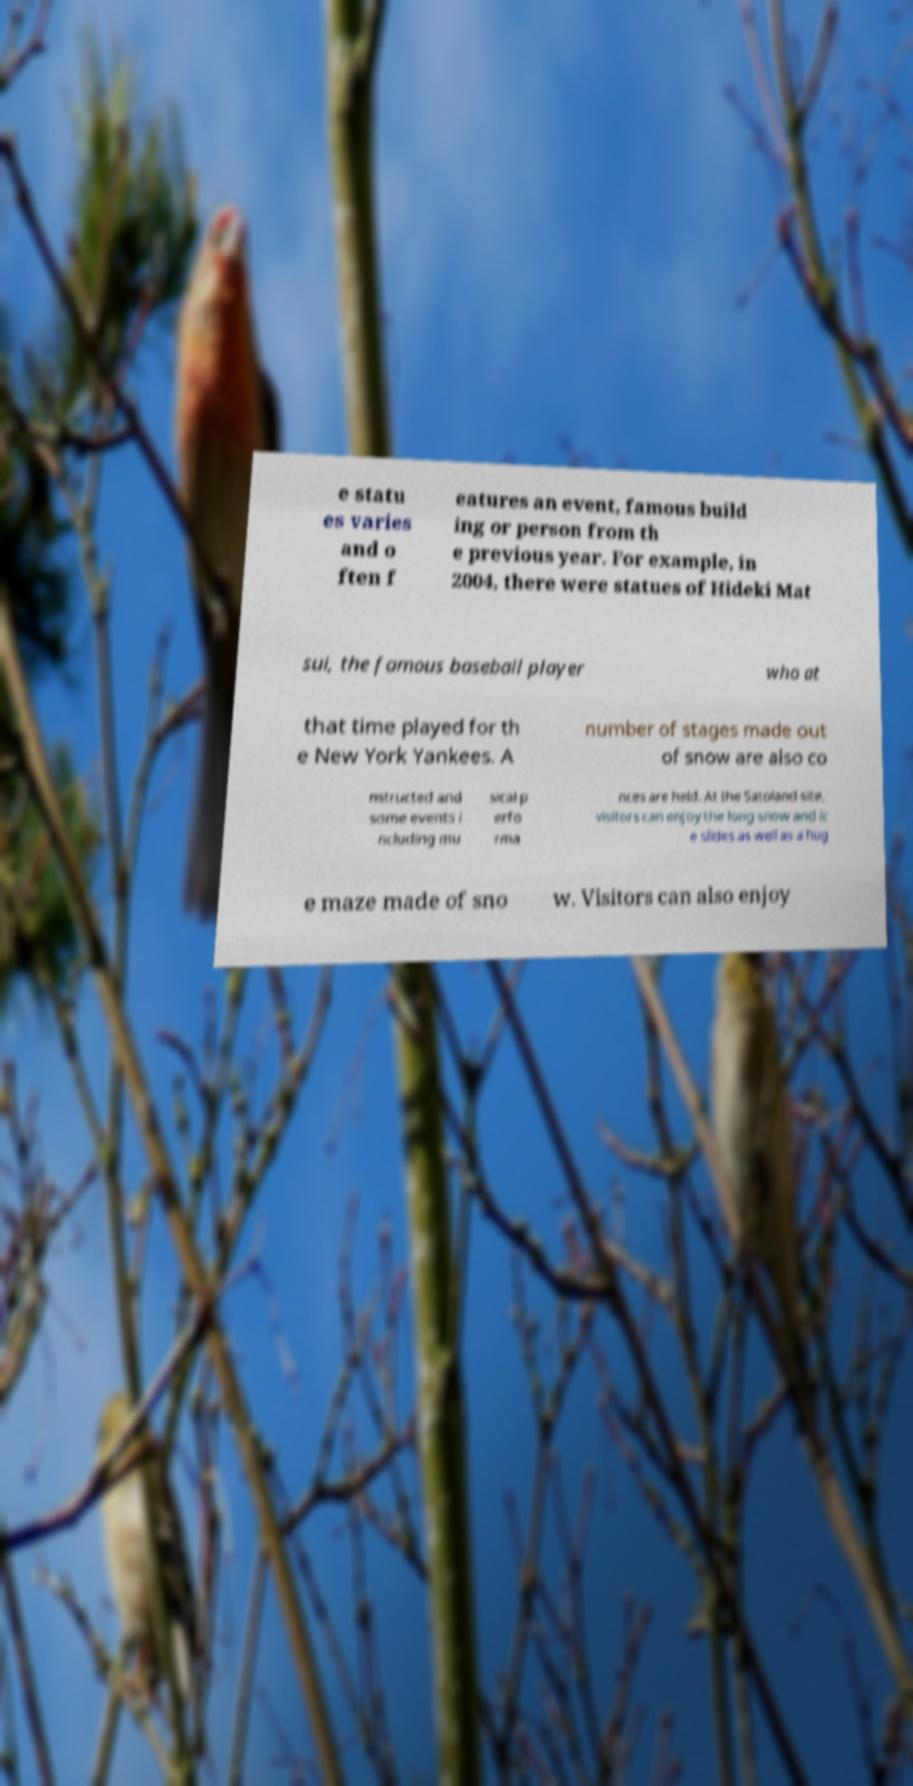Can you read and provide the text displayed in the image?This photo seems to have some interesting text. Can you extract and type it out for me? e statu es varies and o ften f eatures an event, famous build ing or person from th e previous year. For example, in 2004, there were statues of Hideki Mat sui, the famous baseball player who at that time played for th e New York Yankees. A number of stages made out of snow are also co nstructed and some events i ncluding mu sical p erfo rma nces are held. At the Satoland site, visitors can enjoy the long snow and ic e slides as well as a hug e maze made of sno w. Visitors can also enjoy 